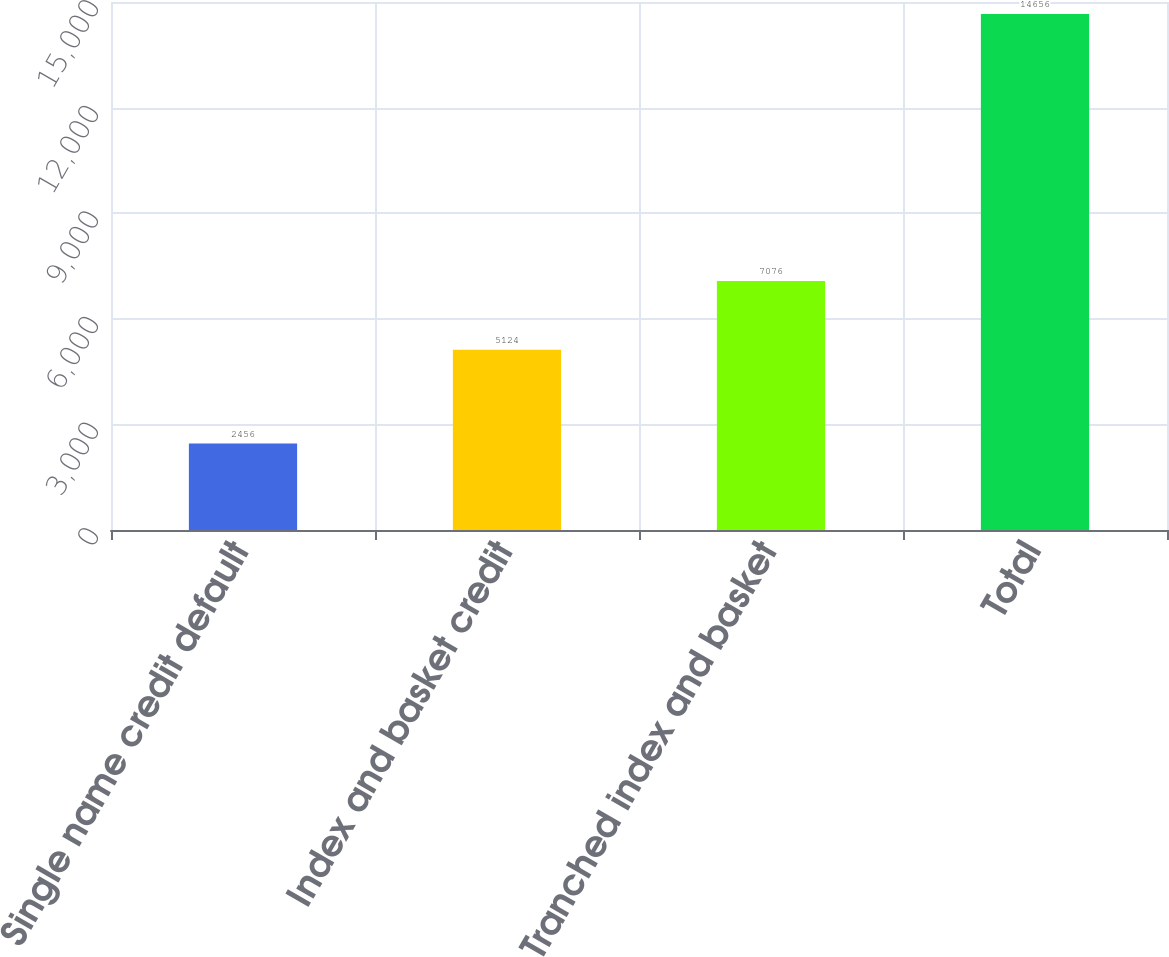Convert chart to OTSL. <chart><loc_0><loc_0><loc_500><loc_500><bar_chart><fcel>Single name credit default<fcel>Index and basket credit<fcel>Tranched index and basket<fcel>Total<nl><fcel>2456<fcel>5124<fcel>7076<fcel>14656<nl></chart> 